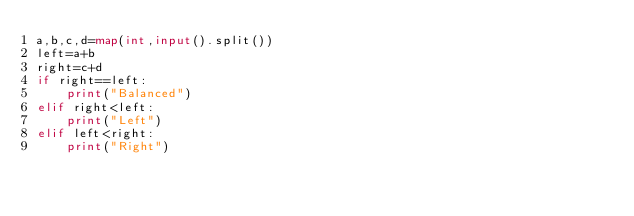Convert code to text. <code><loc_0><loc_0><loc_500><loc_500><_Python_>a,b,c,d=map(int,input().split())
left=a+b
right=c+d
if right==left:
    print("Balanced")
elif right<left:
    print("Left")
elif left<right:
    print("Right")</code> 